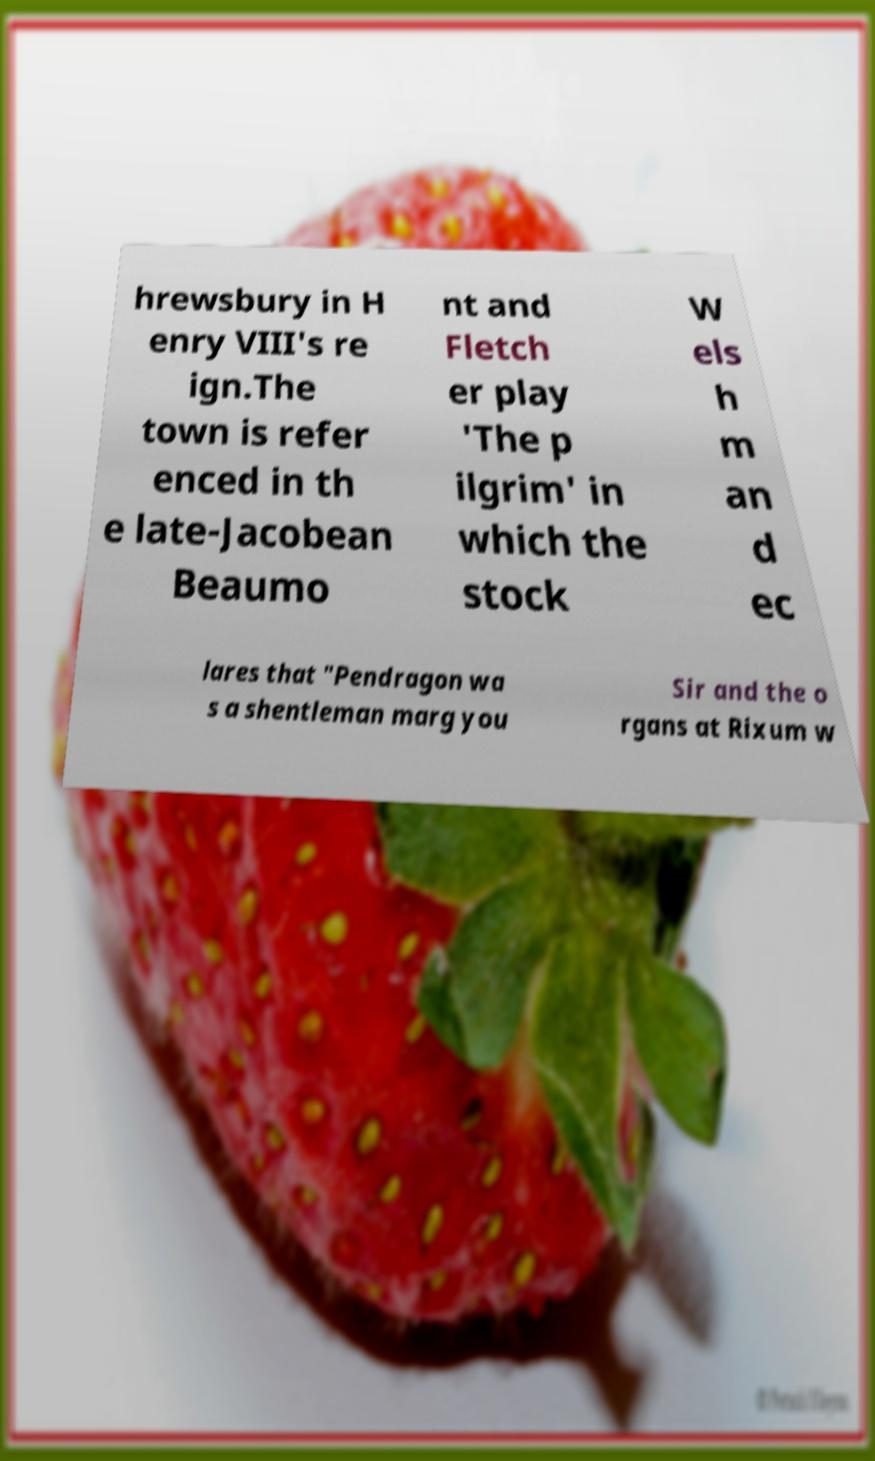I need the written content from this picture converted into text. Can you do that? hrewsbury in H enry VIII's re ign.The town is refer enced in th e late-Jacobean Beaumo nt and Fletch er play 'The p ilgrim' in which the stock W els h m an d ec lares that "Pendragon wa s a shentleman marg you Sir and the o rgans at Rixum w 